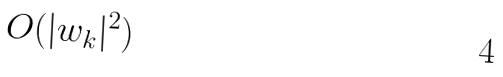Convert formula to latex. <formula><loc_0><loc_0><loc_500><loc_500>O ( | w _ { k } | ^ { 2 } )</formula> 